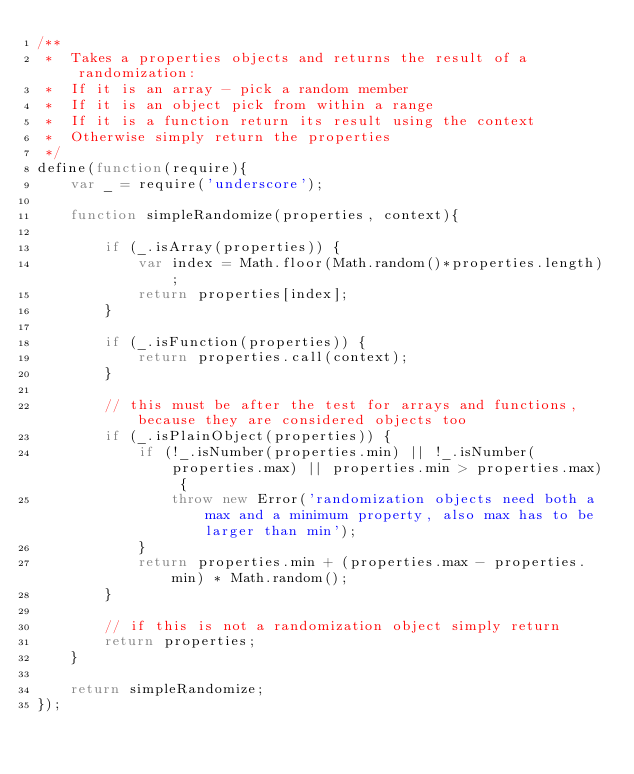<code> <loc_0><loc_0><loc_500><loc_500><_JavaScript_>/**
 *	Takes a properties objects and returns the result of a randomization:
 *	If it is an array - pick a random member
 *	If it is an object pick from within a range
 *	If it is a function return its result using the context
 *	Otherwise simply return the properties
 */
define(function(require){
	var _ = require('underscore');

	function simpleRandomize(properties, context){

		if (_.isArray(properties)) {
			var index = Math.floor(Math.random()*properties.length);
			return properties[index];
		}

		if (_.isFunction(properties)) {
			return properties.call(context);
		}

		// this must be after the test for arrays and functions, because they are considered objects too
		if (_.isPlainObject(properties)) {
			if (!_.isNumber(properties.min) || !_.isNumber(properties.max) || properties.min > properties.max) {
				throw new Error('randomization objects need both a max and a minimum property, also max has to be larger than min');
			}
			return properties.min + (properties.max - properties.min) * Math.random();
		}

		// if this is not a randomization object simply return
		return properties;
	}

	return simpleRandomize;
});</code> 